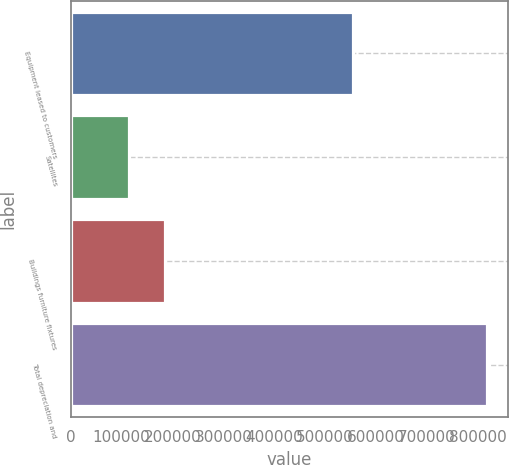<chart> <loc_0><loc_0><loc_500><loc_500><bar_chart><fcel>Equipment leased to customers<fcel>Satellites<fcel>Buildings furniture fixtures<fcel>Total depreciation and<nl><fcel>554272<fcel>114821<fcel>185095<fcel>817564<nl></chart> 